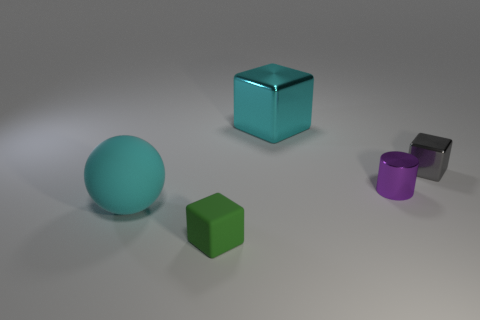How many other objects are the same shape as the big cyan metal object? There are two other objects that share the same cubic shape with the big cyan metal object. Specifically, these are the small green cube and the small grey cube. 